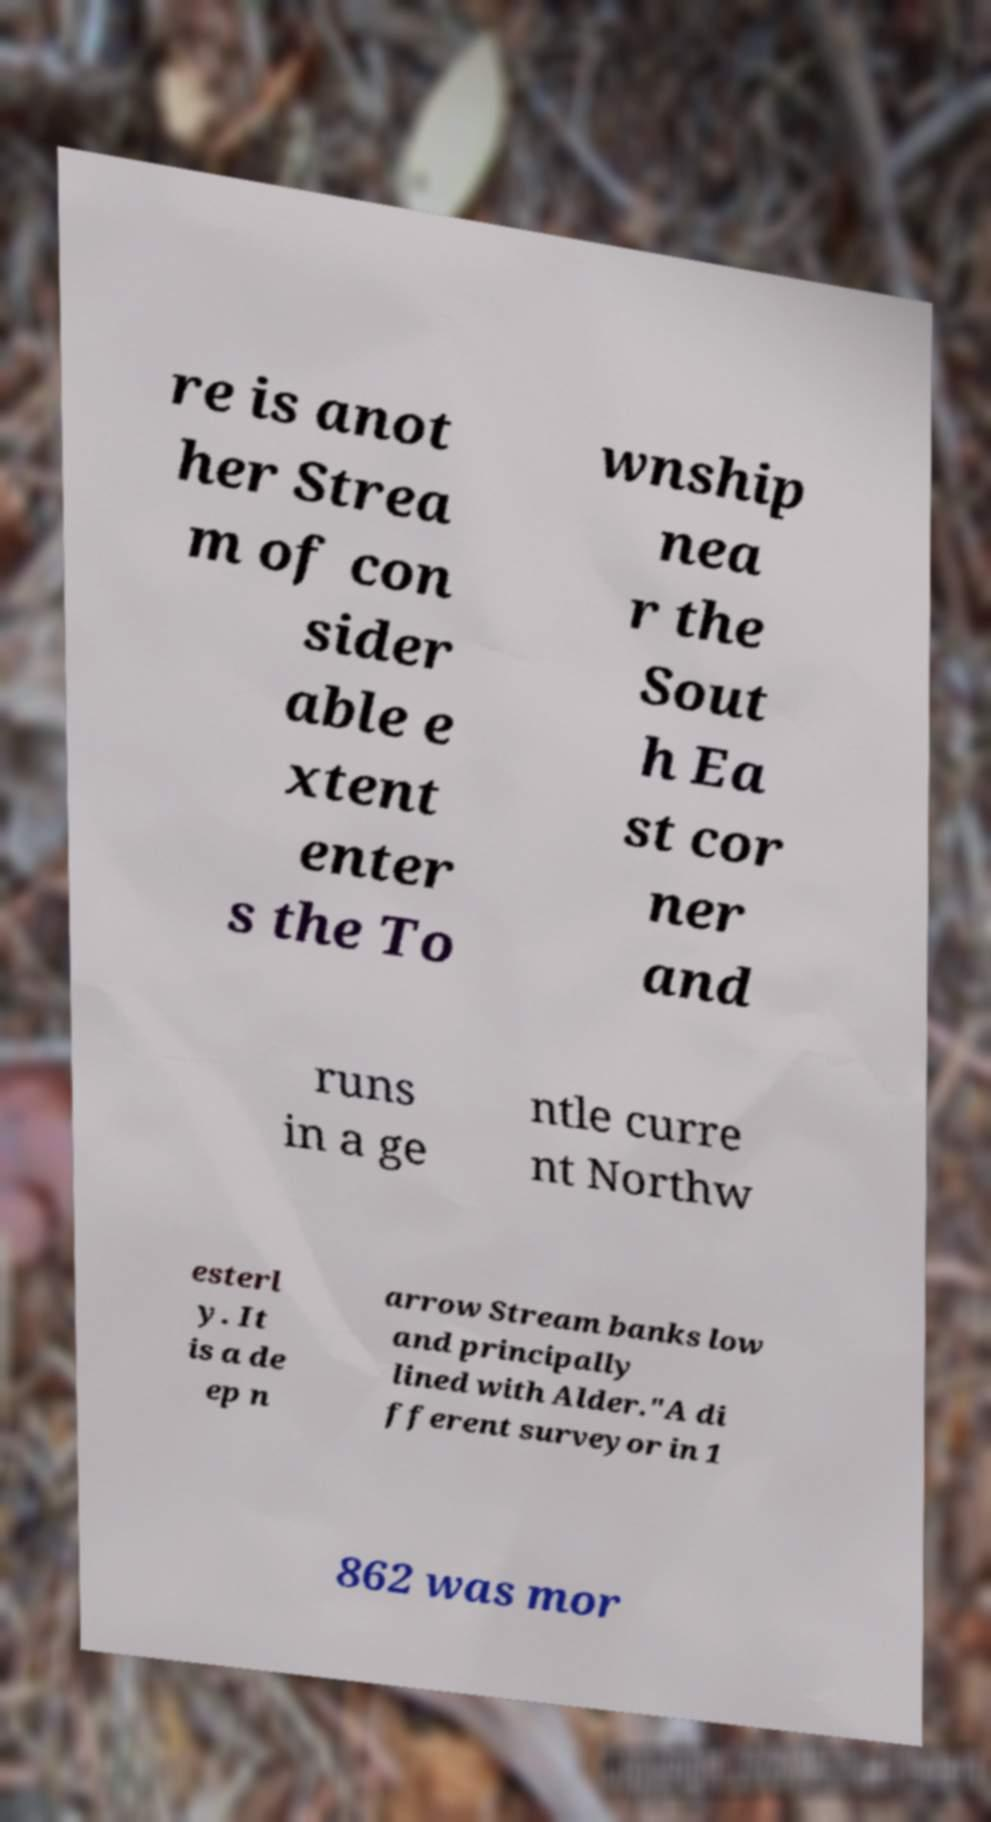For documentation purposes, I need the text within this image transcribed. Could you provide that? re is anot her Strea m of con sider able e xtent enter s the To wnship nea r the Sout h Ea st cor ner and runs in a ge ntle curre nt Northw esterl y. It is a de ep n arrow Stream banks low and principally lined with Alder."A di fferent surveyor in 1 862 was mor 